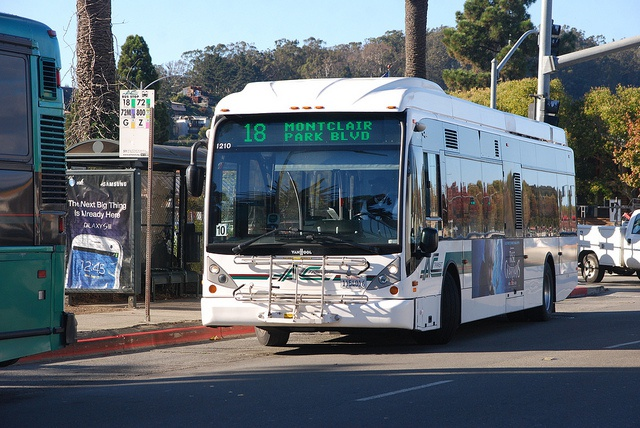Describe the objects in this image and their specific colors. I can see bus in lightblue, black, white, darkgray, and gray tones, bus in lightblue, teal, black, and gray tones, truck in lightblue, white, darkgray, black, and gray tones, bench in lightblue, black, gray, and purple tones, and people in lightblue, darkblue, black, and gray tones in this image. 